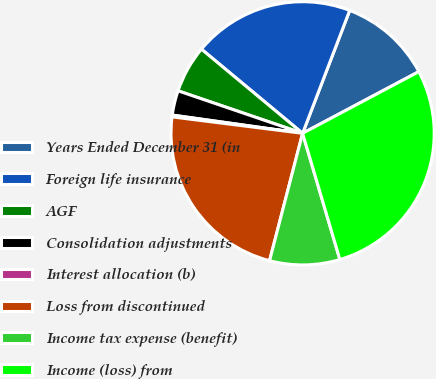<chart> <loc_0><loc_0><loc_500><loc_500><pie_chart><fcel>Years Ended December 31 (in<fcel>Foreign life insurance<fcel>AGF<fcel>Consolidation adjustments<fcel>Interest allocation (b)<fcel>Loss from discontinued<fcel>Income tax expense (benefit)<fcel>Income (loss) from<nl><fcel>11.41%<fcel>19.78%<fcel>5.81%<fcel>3.02%<fcel>0.22%<fcel>22.95%<fcel>8.61%<fcel>28.19%<nl></chart> 